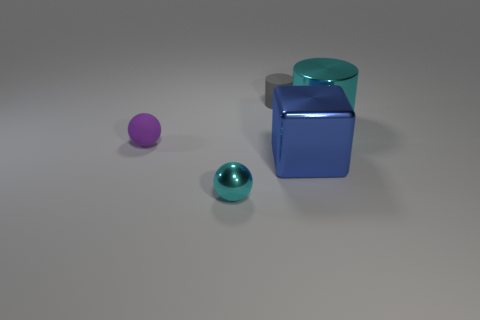Add 1 blue metallic things. How many objects exist? 6 Subtract all cyan spheres. How many spheres are left? 1 Subtract all blue objects. Subtract all tiny things. How many objects are left? 1 Add 4 tiny gray cylinders. How many tiny gray cylinders are left? 5 Add 5 shiny balls. How many shiny balls exist? 6 Subtract 0 yellow spheres. How many objects are left? 5 Subtract all balls. How many objects are left? 3 Subtract 1 blocks. How many blocks are left? 0 Subtract all red cylinders. Subtract all brown balls. How many cylinders are left? 2 Subtract all green balls. How many gray cylinders are left? 1 